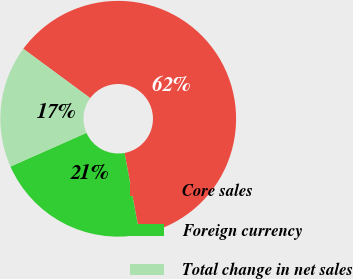Convert chart to OTSL. <chart><loc_0><loc_0><loc_500><loc_500><pie_chart><fcel>Core sales<fcel>Foreign currency<fcel>Total change in net sales<nl><fcel>61.98%<fcel>21.27%<fcel>16.75%<nl></chart> 